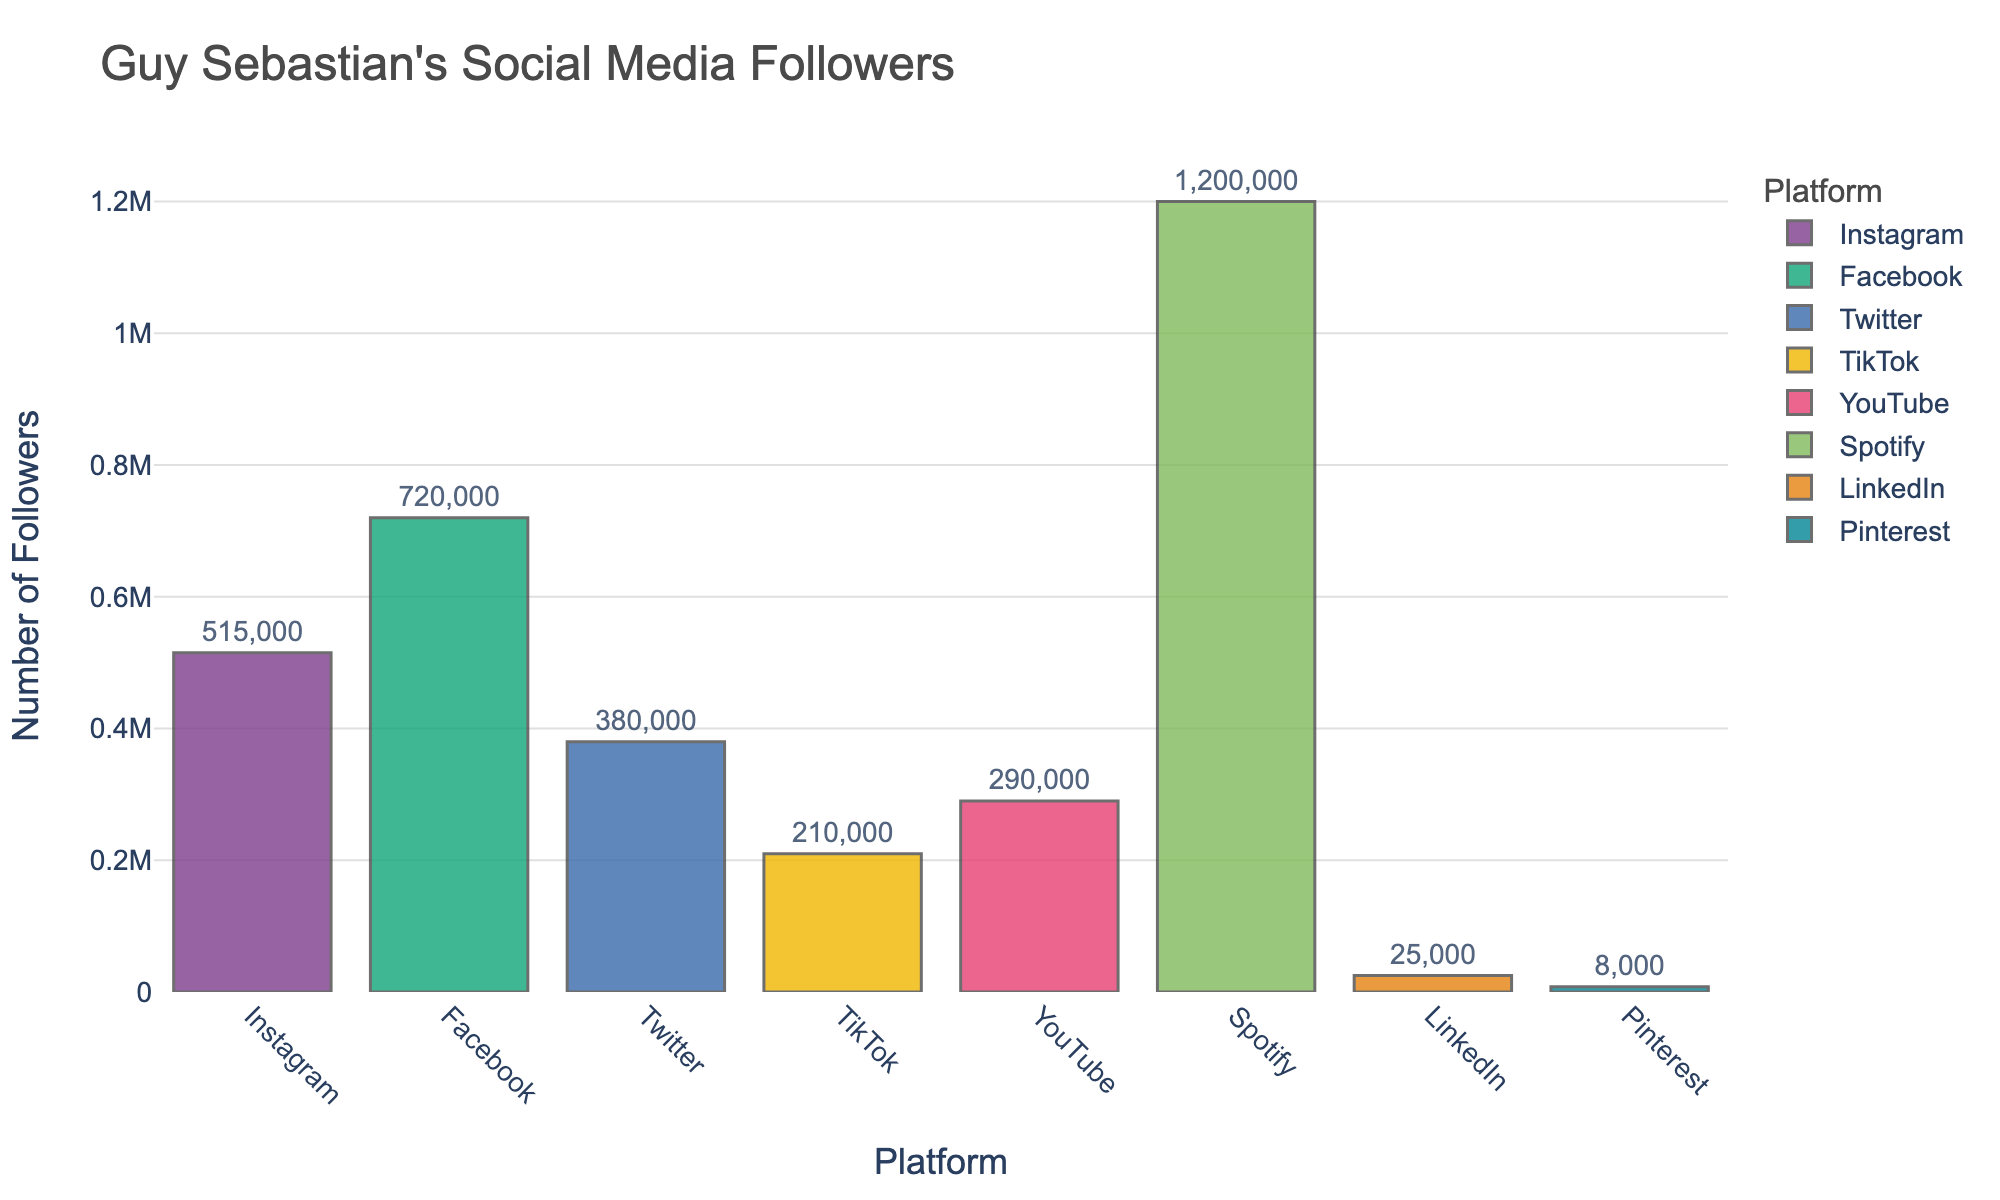What is the total number of followers across all social media platforms? Add up the number of followers from all the social media platforms: Instagram (515000), Facebook (720000), Twitter (380000), TikTok (210000), YouTube (290000), Spotify (1200000), LinkedIn (25000), Pinterest (8000). Total = 515000 + 720000 + 380000 + 210000 + 290000 + 1200000 + 25000 + 8000 = 3142000
Answer: 3,142,000 Which platform has the highest number of followers? By observing the heights of the bars, it's clear that Spotify has the tallest bar, indicating the highest number of followers.
Answer: Spotify Which platform has the lowest number of followers? By observing the heights of the bars, Pinterest has the shortest bar, indicating the lowest number of followers.
Answer: Pinterest How many more followers does Facebook have compared to Twitter? Subtract the number of Twitter followers from the number of Facebook followers: 720000 (Facebook) - 380000 (Twitter) = 340000
Answer: 340,000 What is the average number of followers per platform? Compute the average by summing the total number of followers and dividing by the number of platforms. Total followers = 3,142,000, Number of platforms = 8, Average = 3,142,000 / 8 = 392750
Answer: 392,750 How do the followers on Instagram and TikTok compare? Which has more? Compare the number of Instagram followers (515000) and TikTok followers (210000). Instagram has more followers.
Answer: Instagram What is the combined total of followers for YouTube and LinkedIn? Add the number of YouTube followers to the number of LinkedIn followers: 290000 (YouTube) + 25000 (LinkedIn) = 315000
Answer: 315,000 How many platforms have more than 500,000 followers? Count the number of bars that represent followers greater than 500,000. Platforms: Instagram (515000), Facebook (720000), Spotify (1200000). Total = 3 platforms
Answer: 3 If you exclude Spotify, what is the median number of followers of the remaining platforms? Order the remaining followers: Pinterest (8000), LinkedIn (25000), TikTok (210000), YouTube (290000), Twitter (380000), Instagram (515000), Facebook (720000). The middle value (4th in the sorted list) is 290000 (YouTube).
Answer: 290,000 Which two platforms have the closest number of followers? By comparing the differences, Instagram (515000) and YouTube (290000) with Twitter (380000) and TikTok (210000), Linkedin (25000) and Pinterest (8000), Twitter and TikTok have the smallest absolute difference: 380000 - 210000 = 170000
Answer: Twitter and TikTok 